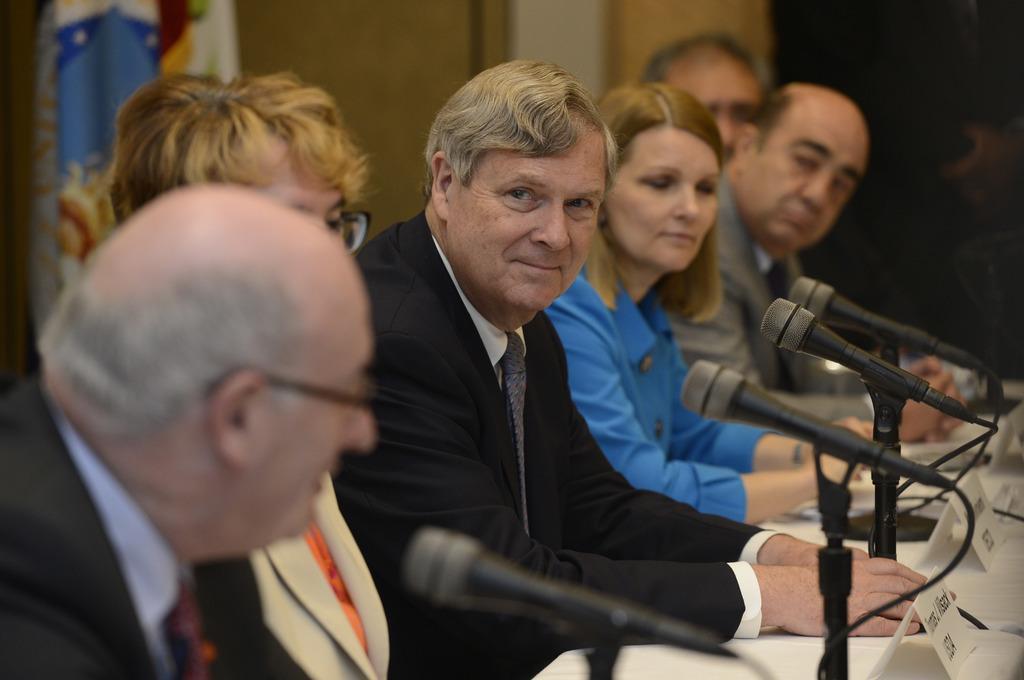Can you describe this image briefly? In this image I can see few people are in front of the mic and there are boards on the table. 